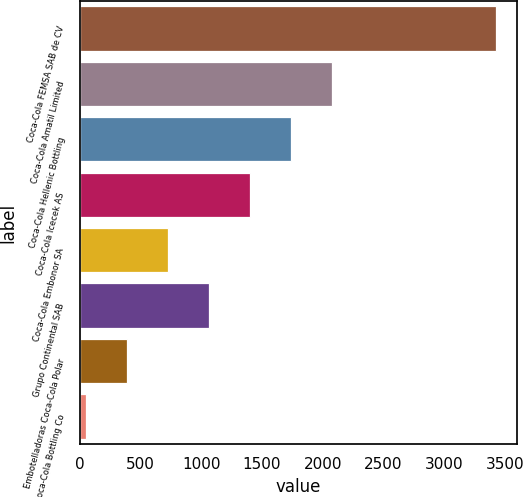<chart> <loc_0><loc_0><loc_500><loc_500><bar_chart><fcel>Coca-Cola FEMSA SAB de CV<fcel>Coca-Cola Amatil Limited<fcel>Coca-Cola Hellenic Bottling<fcel>Coca-Cola Icecek AS<fcel>Coca-Cola Embonor SA<fcel>Grupo Continental SAB<fcel>Embotelladoras Coca-Cola Polar<fcel>Coca-Cola Bottling Co<nl><fcel>3425<fcel>2077<fcel>1740<fcel>1403<fcel>729<fcel>1066<fcel>392<fcel>55<nl></chart> 